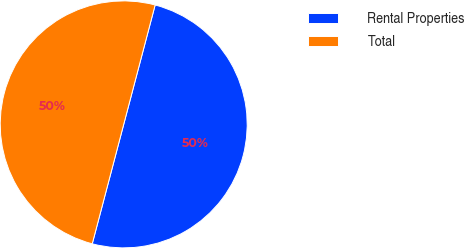Convert chart. <chart><loc_0><loc_0><loc_500><loc_500><pie_chart><fcel>Rental Properties<fcel>Total<nl><fcel>50.0%<fcel>50.0%<nl></chart> 